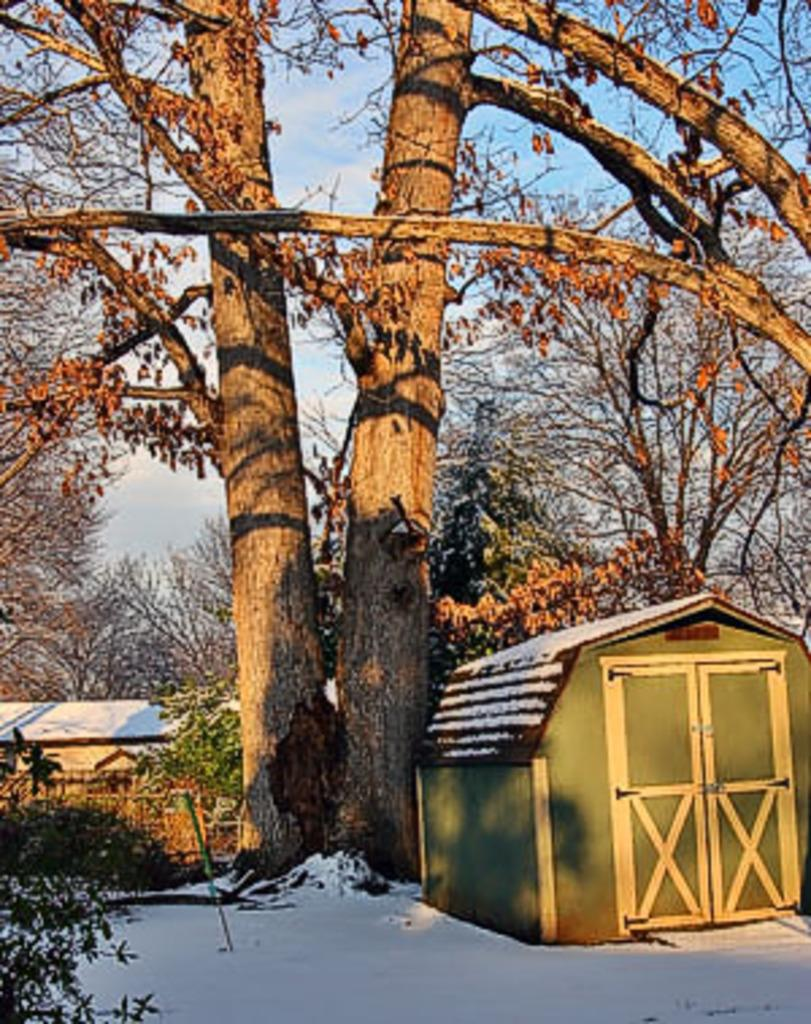What type of houses are visible in the image? There are wooden houses in the image. What other natural elements can be seen in the image? There are trees in the image. What is the condition of the sky in the image? The sky is clear at the top of the image. What is covering the ground in the foreground of the image? There is snow in the foreground of the image. How many kittens are playing with a mask in the image? There are no kittens or masks present in the image. What type of riddle can be solved by looking at the image? There is no riddle associated with the image; it simply depicts wooden houses, trees, a clear sky, and snow-covered ground. 